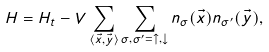Convert formula to latex. <formula><loc_0><loc_0><loc_500><loc_500>H = H _ { t } - V \sum _ { \langle \vec { x } , \vec { y } \rangle } \sum _ { \sigma , \sigma ^ { \prime } = \uparrow , \downarrow } n _ { \sigma } ( \vec { x } ) n _ { \sigma ^ { \prime } } ( \vec { y } ) ,</formula> 